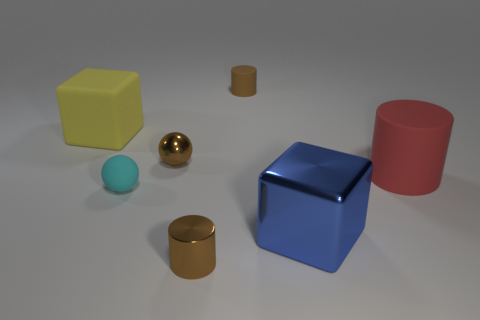Add 2 big green rubber spheres. How many objects exist? 9 Subtract all balls. How many objects are left? 5 Add 3 cyan blocks. How many cyan blocks exist? 3 Subtract 0 green cylinders. How many objects are left? 7 Subtract all big red matte objects. Subtract all metal cubes. How many objects are left? 5 Add 3 big yellow things. How many big yellow things are left? 4 